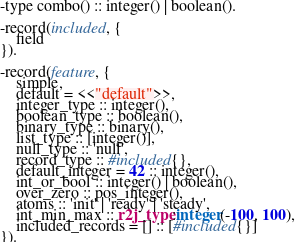Convert code to text. <code><loc_0><loc_0><loc_500><loc_500><_Erlang_>-type combo() :: integer() | boolean().

-record(included, {
    field
}).

-record(feature, {
    simple,
    default = <<"default">>,
    integer_type :: integer(),
    boolean_type :: boolean(),
    binary_type :: binary(),
    list_type :: [integer()],
    null_type :: 'null',
    record_type :: #included{},
    default_integer = 42 :: integer(),
    int_or_bool :: integer() | boolean(),
    over_zero :: pos_integer(),
    atoms :: 'init' | 'ready' | 'steady',
    int_min_max :: r2j_type:integer(-100, 100),
    included_records = [] :: [#included{}]
}).
</code> 